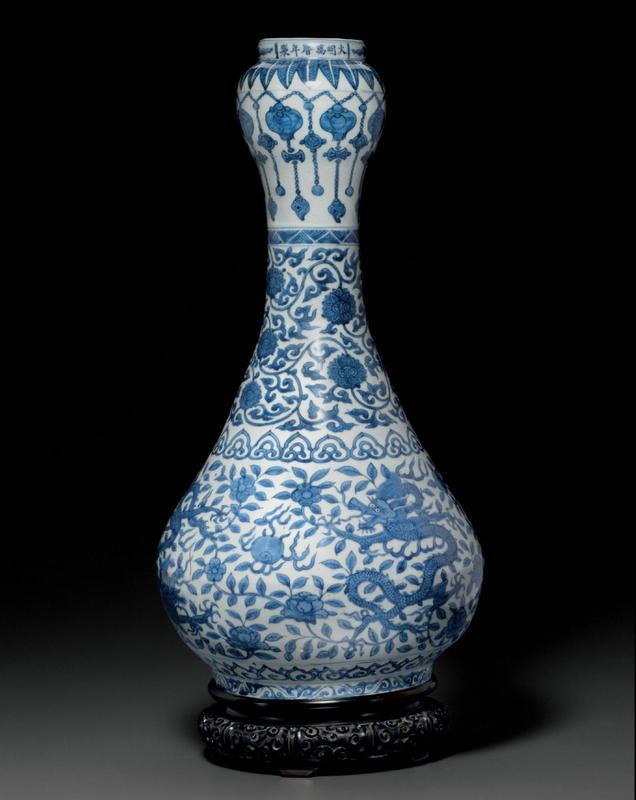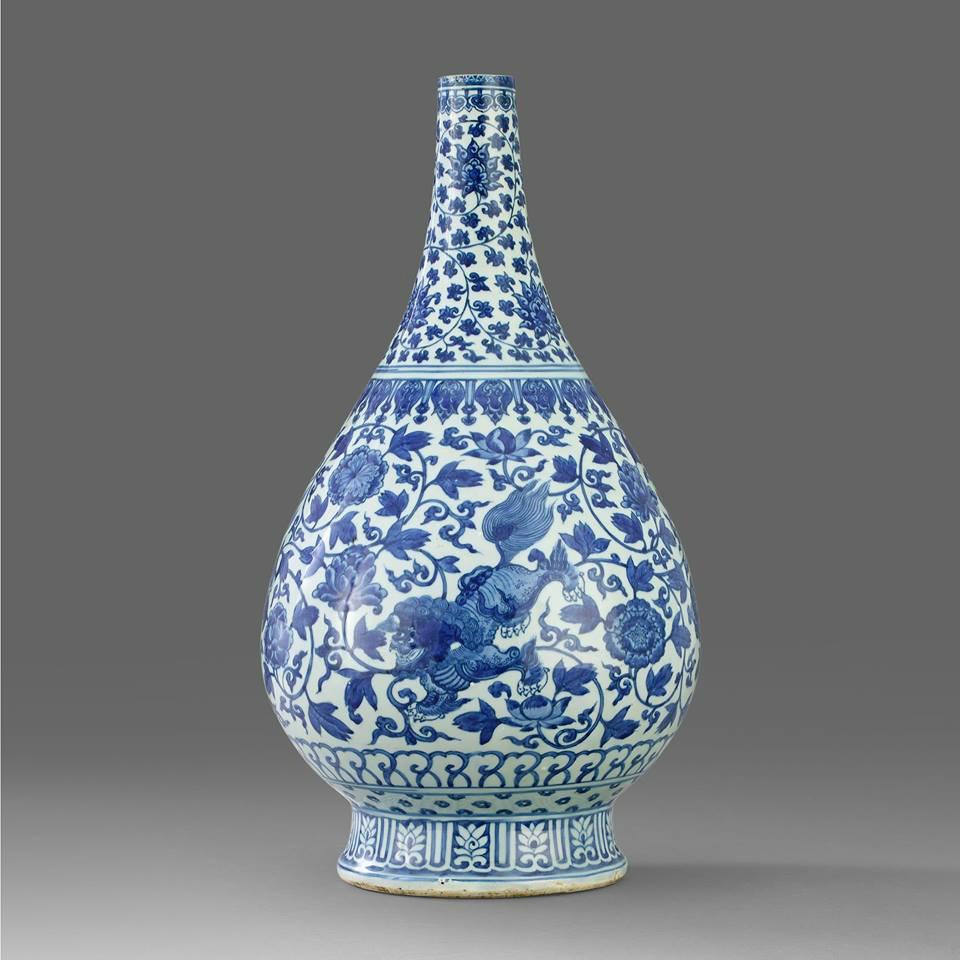The first image is the image on the left, the second image is the image on the right. Evaluate the accuracy of this statement regarding the images: "One vase has a bulge in the stem.". Is it true? Answer yes or no. Yes. The first image is the image on the left, the second image is the image on the right. Considering the images on both sides, is "The vases in the left and right images do not have the same shape, and at least one vase features a dragon-like creature on it." valid? Answer yes or no. Yes. 